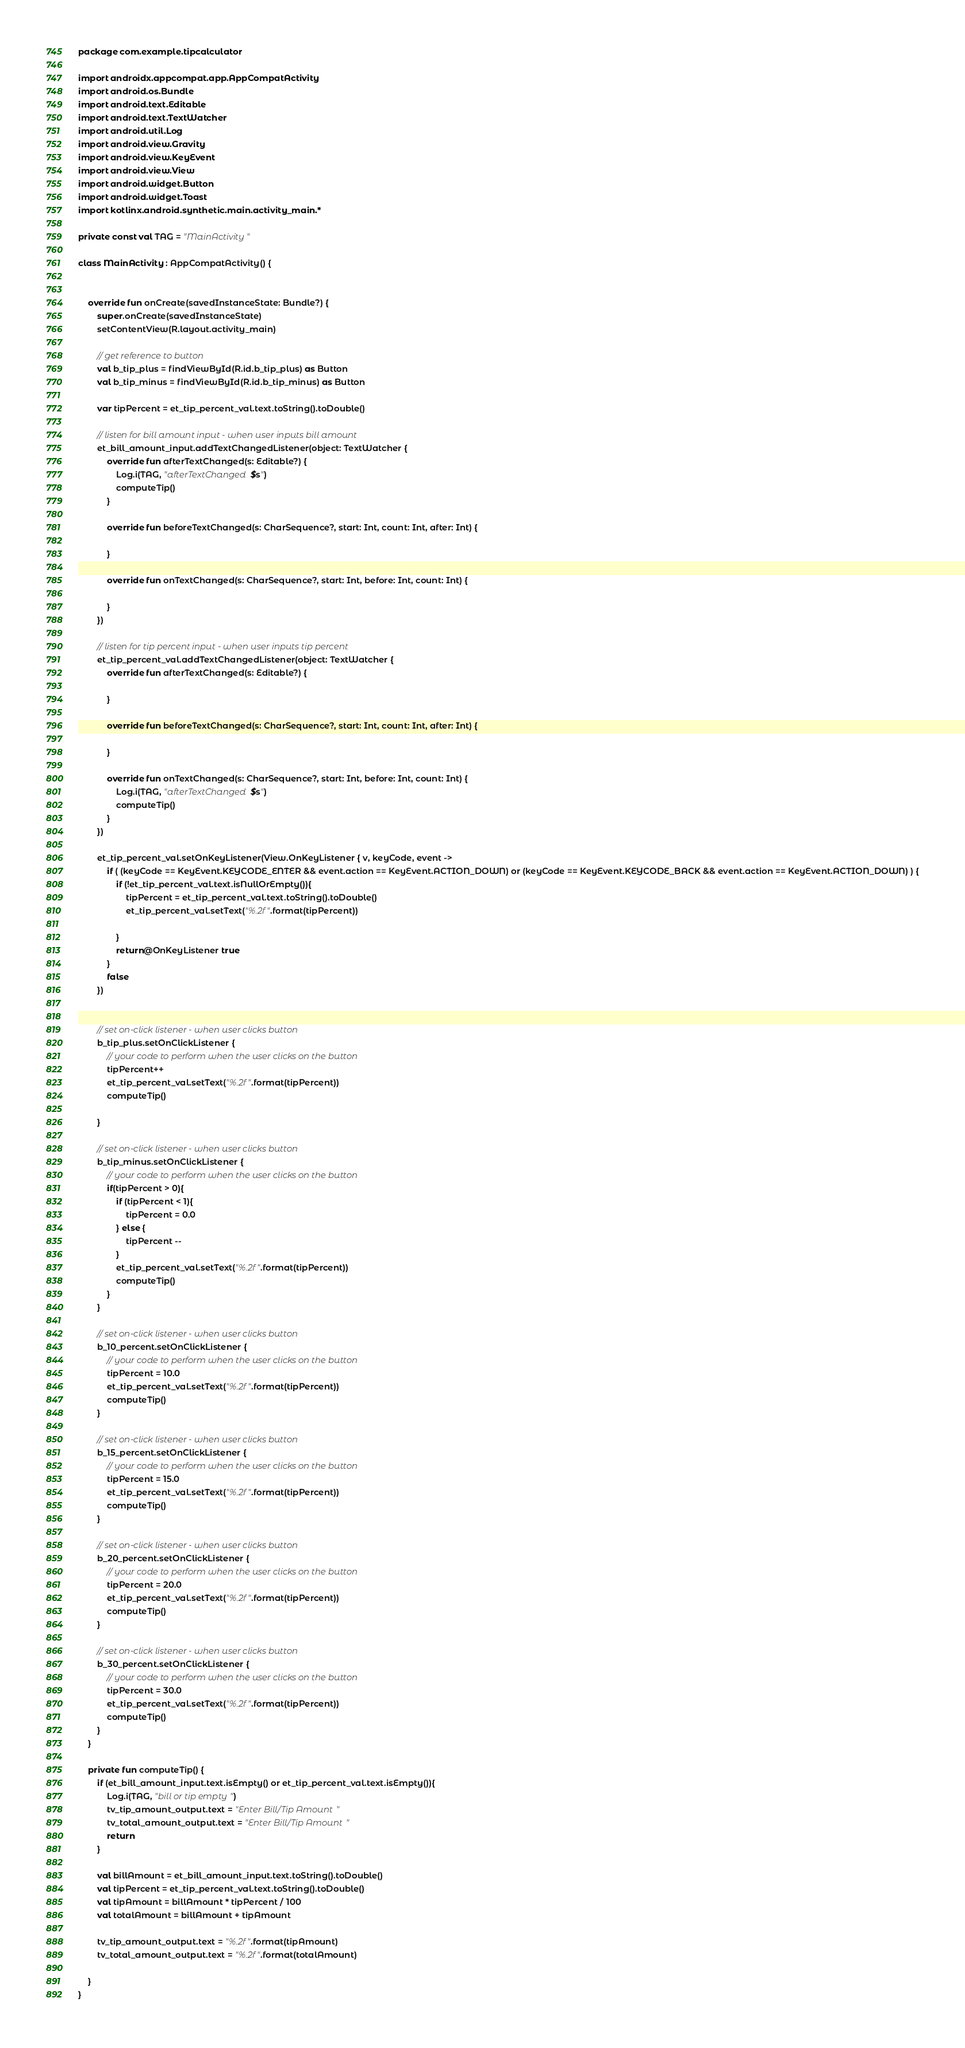<code> <loc_0><loc_0><loc_500><loc_500><_Kotlin_>package com.example.tipcalculator

import androidx.appcompat.app.AppCompatActivity
import android.os.Bundle
import android.text.Editable
import android.text.TextWatcher
import android.util.Log
import android.view.Gravity
import android.view.KeyEvent
import android.view.View
import android.widget.Button
import android.widget.Toast
import kotlinx.android.synthetic.main.activity_main.*

private const val TAG = "MainActivity"

class MainActivity : AppCompatActivity() {


    override fun onCreate(savedInstanceState: Bundle?) {
        super.onCreate(savedInstanceState)
        setContentView(R.layout.activity_main)

        // get reference to button
        val b_tip_plus = findViewById(R.id.b_tip_plus) as Button
        val b_tip_minus = findViewById(R.id.b_tip_minus) as Button

        var tipPercent = et_tip_percent_val.text.toString().toDouble()

        // listen for bill amount input - when user inputs bill amount
        et_bill_amount_input.addTextChangedListener(object: TextWatcher {
            override fun afterTextChanged(s: Editable?) {
                Log.i(TAG, "afterTextChanged $s")
                computeTip()
            }

            override fun beforeTextChanged(s: CharSequence?, start: Int, count: Int, after: Int) {

            }

            override fun onTextChanged(s: CharSequence?, start: Int, before: Int, count: Int) {

            }
        })

        // listen for tip percent input - when user inputs tip percent
        et_tip_percent_val.addTextChangedListener(object: TextWatcher {
            override fun afterTextChanged(s: Editable?) {

            }

            override fun beforeTextChanged(s: CharSequence?, start: Int, count: Int, after: Int) {

            }

            override fun onTextChanged(s: CharSequence?, start: Int, before: Int, count: Int) {
                Log.i(TAG, "afterTextChanged $s")
                computeTip()
            }
        })

        et_tip_percent_val.setOnKeyListener(View.OnKeyListener { v, keyCode, event ->
            if ( (keyCode == KeyEvent.KEYCODE_ENTER && event.action == KeyEvent.ACTION_DOWN) or (keyCode == KeyEvent.KEYCODE_BACK && event.action == KeyEvent.ACTION_DOWN) ) {
                if (!et_tip_percent_val.text.isNullOrEmpty()){
                    tipPercent = et_tip_percent_val.text.toString().toDouble()
                    et_tip_percent_val.setText("%.2f".format(tipPercent))

                }
                return@OnKeyListener true
            }
            false
        })


        // set on-click listener - when user clicks button
        b_tip_plus.setOnClickListener {
            // your code to perform when the user clicks on the button
            tipPercent++
            et_tip_percent_val.setText("%.2f".format(tipPercent))
            computeTip()

        }

        // set on-click listener - when user clicks button
        b_tip_minus.setOnClickListener {
            // your code to perform when the user clicks on the button
            if(tipPercent > 0){
                if (tipPercent < 1){
                    tipPercent = 0.0
                } else {
                    tipPercent --
                }
                et_tip_percent_val.setText("%.2f".format(tipPercent))
                computeTip()
            }
        }

        // set on-click listener - when user clicks button
        b_10_percent.setOnClickListener {
            // your code to perform when the user clicks on the button
            tipPercent = 10.0
            et_tip_percent_val.setText("%.2f".format(tipPercent))
            computeTip()
        }

        // set on-click listener - when user clicks button
        b_15_percent.setOnClickListener {
            // your code to perform when the user clicks on the button
            tipPercent = 15.0
            et_tip_percent_val.setText("%.2f".format(tipPercent))
            computeTip()
        }

        // set on-click listener - when user clicks button
        b_20_percent.setOnClickListener {
            // your code to perform when the user clicks on the button
            tipPercent = 20.0
            et_tip_percent_val.setText("%.2f".format(tipPercent))
            computeTip()
        }

        // set on-click listener - when user clicks button
        b_30_percent.setOnClickListener {
            // your code to perform when the user clicks on the button
            tipPercent = 30.0
            et_tip_percent_val.setText("%.2f".format(tipPercent))
            computeTip()
        }
    }

    private fun computeTip() {
        if (et_bill_amount_input.text.isEmpty() or et_tip_percent_val.text.isEmpty()){
            Log.i(TAG, "bill or tip empty")
            tv_tip_amount_output.text = "Enter Bill/Tip Amount"
            tv_total_amount_output.text = "Enter Bill/Tip Amount"
            return
        }

        val billAmount = et_bill_amount_input.text.toString().toDouble()
        val tipPercent = et_tip_percent_val.text.toString().toDouble()
        val tipAmount = billAmount * tipPercent / 100
        val totalAmount = billAmount + tipAmount

        tv_tip_amount_output.text = "%.2f".format(tipAmount)
        tv_total_amount_output.text = "%.2f".format(totalAmount)

    }
}

</code> 